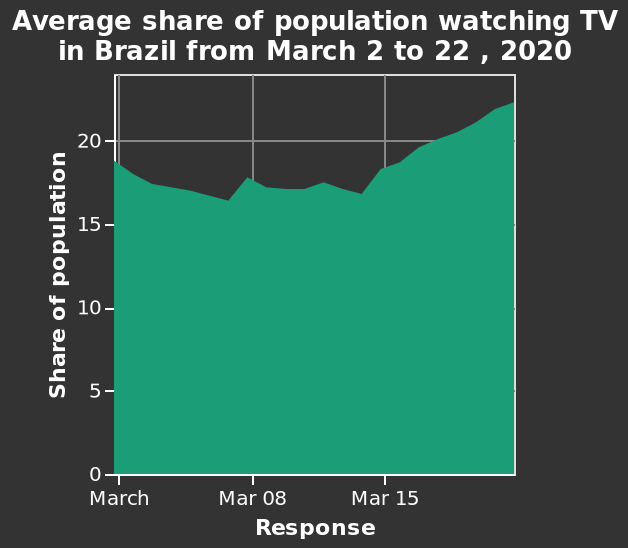<image>
What does the y-axis measure in the area diagram? The y-axis measures the share of population. When was the last few days of the time period? The last few days of the time period studied were between March 20 and March 22. What kind of data is represented by the area diagram? The area diagram represents the average share of population watching TV in Brazil over a specified time period. 